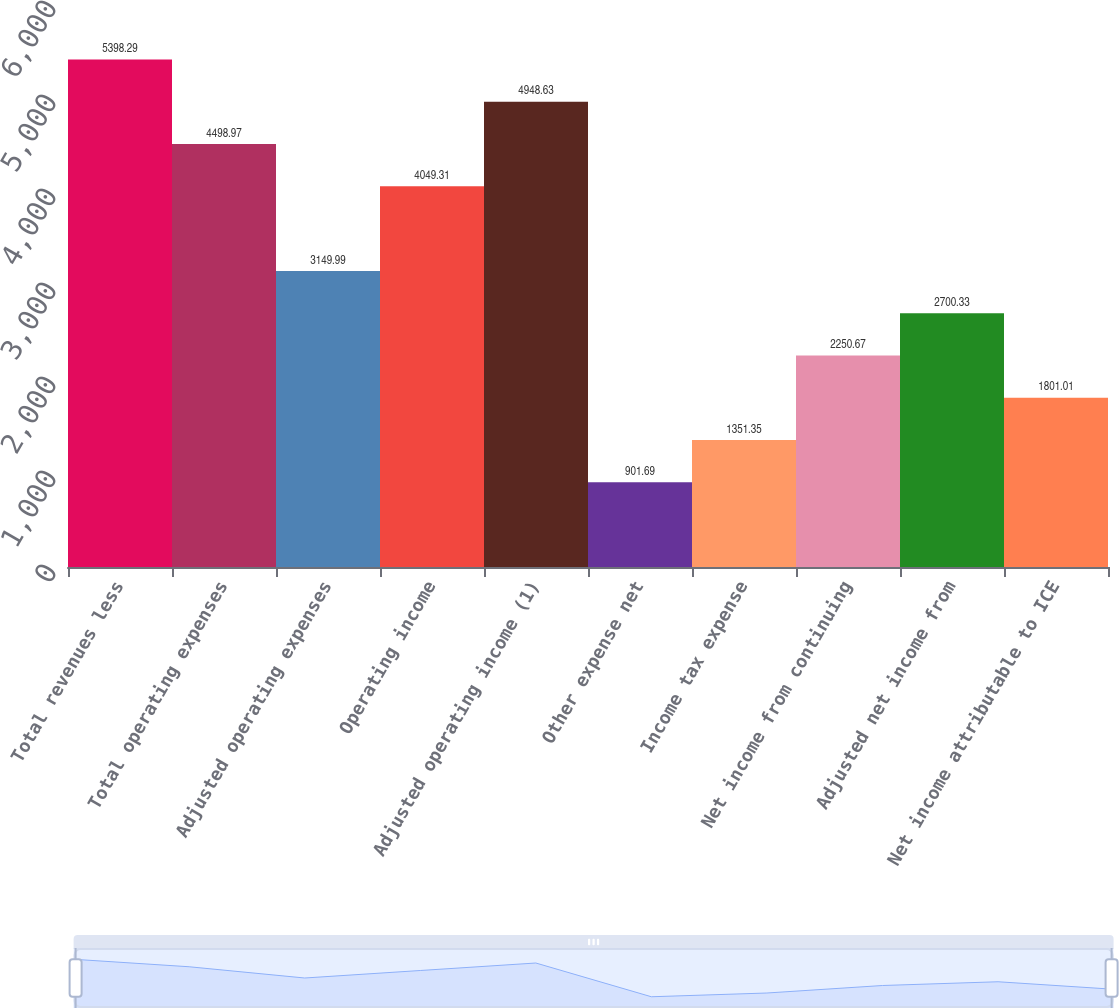Convert chart. <chart><loc_0><loc_0><loc_500><loc_500><bar_chart><fcel>Total revenues less<fcel>Total operating expenses<fcel>Adjusted operating expenses<fcel>Operating income<fcel>Adjusted operating income (1)<fcel>Other expense net<fcel>Income tax expense<fcel>Net income from continuing<fcel>Adjusted net income from<fcel>Net income attributable to ICE<nl><fcel>5398.29<fcel>4498.97<fcel>3149.99<fcel>4049.31<fcel>4948.63<fcel>901.69<fcel>1351.35<fcel>2250.67<fcel>2700.33<fcel>1801.01<nl></chart> 